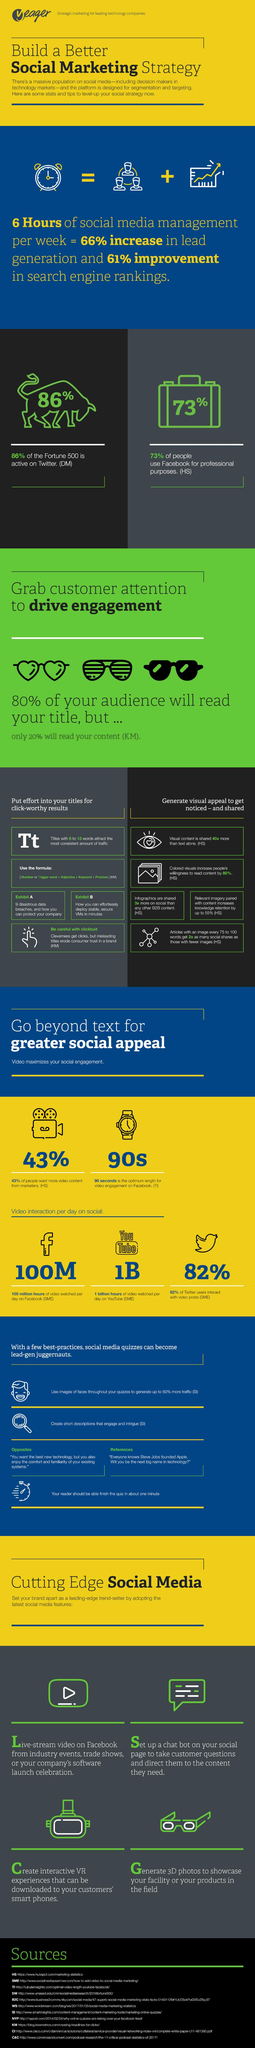Highlight a few significant elements in this photo. According to a recent study, only about 14% of Fortune 500 companies are not active on Twitter. According to data, YouTube has the second highest number of video interactions per day among social media platforms, following Facebook. It is estimated that over 1 billion hours of YouTube videos are watched every day. According to a recent survey, a significant portion of the population does not use Facebook. Specifically, 27% of respondents indicated that they do not use the social media platform. It is estimated that approximately 57% of people do not want more video content from marketers. 